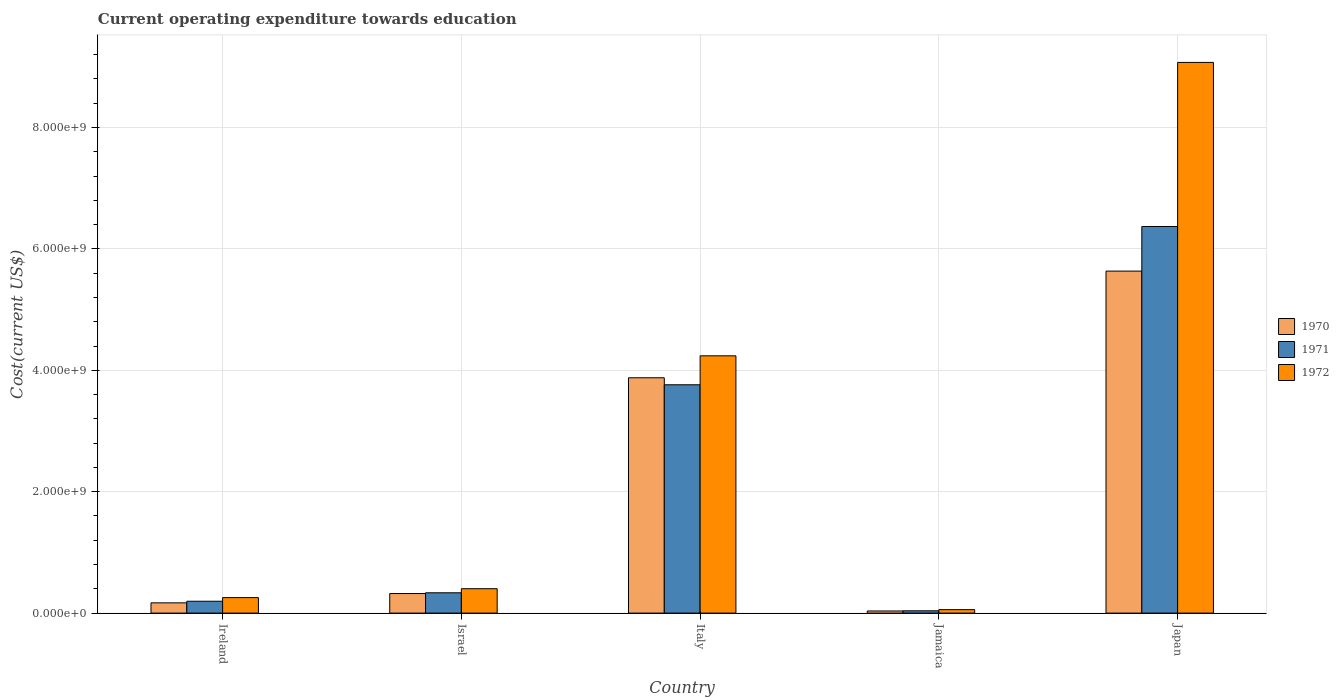Are the number of bars per tick equal to the number of legend labels?
Your answer should be very brief. Yes. Are the number of bars on each tick of the X-axis equal?
Ensure brevity in your answer.  Yes. How many bars are there on the 5th tick from the right?
Your answer should be compact. 3. What is the label of the 4th group of bars from the left?
Your answer should be very brief. Jamaica. What is the expenditure towards education in 1971 in Japan?
Your answer should be very brief. 6.37e+09. Across all countries, what is the maximum expenditure towards education in 1971?
Ensure brevity in your answer.  6.37e+09. Across all countries, what is the minimum expenditure towards education in 1972?
Give a very brief answer. 5.71e+07. In which country was the expenditure towards education in 1971 maximum?
Keep it short and to the point. Japan. In which country was the expenditure towards education in 1970 minimum?
Give a very brief answer. Jamaica. What is the total expenditure towards education in 1971 in the graph?
Keep it short and to the point. 1.07e+1. What is the difference between the expenditure towards education in 1972 in Ireland and that in Japan?
Provide a short and direct response. -8.82e+09. What is the difference between the expenditure towards education in 1971 in Japan and the expenditure towards education in 1970 in Jamaica?
Offer a terse response. 6.33e+09. What is the average expenditure towards education in 1972 per country?
Your response must be concise. 2.80e+09. What is the difference between the expenditure towards education of/in 1970 and expenditure towards education of/in 1972 in Italy?
Your response must be concise. -3.62e+08. What is the ratio of the expenditure towards education in 1970 in Ireland to that in Israel?
Offer a terse response. 0.52. What is the difference between the highest and the second highest expenditure towards education in 1972?
Keep it short and to the point. 8.67e+09. What is the difference between the highest and the lowest expenditure towards education in 1971?
Give a very brief answer. 6.33e+09. Is the sum of the expenditure towards education in 1971 in Ireland and Jamaica greater than the maximum expenditure towards education in 1972 across all countries?
Give a very brief answer. No. Is it the case that in every country, the sum of the expenditure towards education in 1972 and expenditure towards education in 1971 is greater than the expenditure towards education in 1970?
Ensure brevity in your answer.  Yes. How many bars are there?
Your answer should be compact. 15. Does the graph contain any zero values?
Provide a short and direct response. No. Does the graph contain grids?
Make the answer very short. Yes. How many legend labels are there?
Provide a succinct answer. 3. How are the legend labels stacked?
Your answer should be compact. Vertical. What is the title of the graph?
Make the answer very short. Current operating expenditure towards education. Does "1983" appear as one of the legend labels in the graph?
Your answer should be compact. No. What is the label or title of the Y-axis?
Give a very brief answer. Cost(current US$). What is the Cost(current US$) of 1970 in Ireland?
Your answer should be compact. 1.69e+08. What is the Cost(current US$) of 1971 in Ireland?
Provide a short and direct response. 1.95e+08. What is the Cost(current US$) of 1972 in Ireland?
Give a very brief answer. 2.55e+08. What is the Cost(current US$) of 1970 in Israel?
Keep it short and to the point. 3.22e+08. What is the Cost(current US$) of 1971 in Israel?
Keep it short and to the point. 3.34e+08. What is the Cost(current US$) of 1972 in Israel?
Give a very brief answer. 4.02e+08. What is the Cost(current US$) of 1970 in Italy?
Give a very brief answer. 3.88e+09. What is the Cost(current US$) in 1971 in Italy?
Your answer should be compact. 3.76e+09. What is the Cost(current US$) in 1972 in Italy?
Keep it short and to the point. 4.24e+09. What is the Cost(current US$) of 1970 in Jamaica?
Give a very brief answer. 3.49e+07. What is the Cost(current US$) of 1971 in Jamaica?
Offer a terse response. 3.77e+07. What is the Cost(current US$) of 1972 in Jamaica?
Keep it short and to the point. 5.71e+07. What is the Cost(current US$) of 1970 in Japan?
Provide a short and direct response. 5.63e+09. What is the Cost(current US$) of 1971 in Japan?
Your answer should be very brief. 6.37e+09. What is the Cost(current US$) of 1972 in Japan?
Provide a succinct answer. 9.07e+09. Across all countries, what is the maximum Cost(current US$) in 1970?
Your response must be concise. 5.63e+09. Across all countries, what is the maximum Cost(current US$) in 1971?
Make the answer very short. 6.37e+09. Across all countries, what is the maximum Cost(current US$) in 1972?
Your answer should be very brief. 9.07e+09. Across all countries, what is the minimum Cost(current US$) of 1970?
Your answer should be very brief. 3.49e+07. Across all countries, what is the minimum Cost(current US$) in 1971?
Offer a very short reply. 3.77e+07. Across all countries, what is the minimum Cost(current US$) of 1972?
Your answer should be very brief. 5.71e+07. What is the total Cost(current US$) in 1970 in the graph?
Give a very brief answer. 1.00e+1. What is the total Cost(current US$) of 1971 in the graph?
Your response must be concise. 1.07e+1. What is the total Cost(current US$) in 1972 in the graph?
Your response must be concise. 1.40e+1. What is the difference between the Cost(current US$) of 1970 in Ireland and that in Israel?
Keep it short and to the point. -1.53e+08. What is the difference between the Cost(current US$) of 1971 in Ireland and that in Israel?
Offer a very short reply. -1.39e+08. What is the difference between the Cost(current US$) of 1972 in Ireland and that in Israel?
Keep it short and to the point. -1.47e+08. What is the difference between the Cost(current US$) of 1970 in Ireland and that in Italy?
Your answer should be compact. -3.71e+09. What is the difference between the Cost(current US$) of 1971 in Ireland and that in Italy?
Provide a short and direct response. -3.57e+09. What is the difference between the Cost(current US$) in 1972 in Ireland and that in Italy?
Your answer should be very brief. -3.98e+09. What is the difference between the Cost(current US$) in 1970 in Ireland and that in Jamaica?
Provide a succinct answer. 1.34e+08. What is the difference between the Cost(current US$) of 1971 in Ireland and that in Jamaica?
Provide a succinct answer. 1.57e+08. What is the difference between the Cost(current US$) in 1972 in Ireland and that in Jamaica?
Ensure brevity in your answer.  1.98e+08. What is the difference between the Cost(current US$) of 1970 in Ireland and that in Japan?
Your answer should be compact. -5.47e+09. What is the difference between the Cost(current US$) in 1971 in Ireland and that in Japan?
Give a very brief answer. -6.17e+09. What is the difference between the Cost(current US$) of 1972 in Ireland and that in Japan?
Provide a succinct answer. -8.82e+09. What is the difference between the Cost(current US$) in 1970 in Israel and that in Italy?
Your response must be concise. -3.55e+09. What is the difference between the Cost(current US$) in 1971 in Israel and that in Italy?
Offer a terse response. -3.43e+09. What is the difference between the Cost(current US$) of 1972 in Israel and that in Italy?
Offer a terse response. -3.84e+09. What is the difference between the Cost(current US$) of 1970 in Israel and that in Jamaica?
Your answer should be very brief. 2.87e+08. What is the difference between the Cost(current US$) of 1971 in Israel and that in Jamaica?
Provide a succinct answer. 2.97e+08. What is the difference between the Cost(current US$) in 1972 in Israel and that in Jamaica?
Provide a succinct answer. 3.45e+08. What is the difference between the Cost(current US$) of 1970 in Israel and that in Japan?
Provide a short and direct response. -5.31e+09. What is the difference between the Cost(current US$) of 1971 in Israel and that in Japan?
Your answer should be very brief. -6.03e+09. What is the difference between the Cost(current US$) in 1972 in Israel and that in Japan?
Offer a terse response. -8.67e+09. What is the difference between the Cost(current US$) of 1970 in Italy and that in Jamaica?
Offer a terse response. 3.84e+09. What is the difference between the Cost(current US$) of 1971 in Italy and that in Jamaica?
Your answer should be compact. 3.72e+09. What is the difference between the Cost(current US$) in 1972 in Italy and that in Jamaica?
Your response must be concise. 4.18e+09. What is the difference between the Cost(current US$) in 1970 in Italy and that in Japan?
Your answer should be compact. -1.76e+09. What is the difference between the Cost(current US$) of 1971 in Italy and that in Japan?
Offer a very short reply. -2.61e+09. What is the difference between the Cost(current US$) of 1972 in Italy and that in Japan?
Provide a short and direct response. -4.83e+09. What is the difference between the Cost(current US$) of 1970 in Jamaica and that in Japan?
Keep it short and to the point. -5.60e+09. What is the difference between the Cost(current US$) of 1971 in Jamaica and that in Japan?
Offer a very short reply. -6.33e+09. What is the difference between the Cost(current US$) of 1972 in Jamaica and that in Japan?
Provide a short and direct response. -9.02e+09. What is the difference between the Cost(current US$) in 1970 in Ireland and the Cost(current US$) in 1971 in Israel?
Offer a very short reply. -1.66e+08. What is the difference between the Cost(current US$) of 1970 in Ireland and the Cost(current US$) of 1972 in Israel?
Offer a terse response. -2.33e+08. What is the difference between the Cost(current US$) in 1971 in Ireland and the Cost(current US$) in 1972 in Israel?
Offer a terse response. -2.07e+08. What is the difference between the Cost(current US$) in 1970 in Ireland and the Cost(current US$) in 1971 in Italy?
Give a very brief answer. -3.59e+09. What is the difference between the Cost(current US$) in 1970 in Ireland and the Cost(current US$) in 1972 in Italy?
Your answer should be compact. -4.07e+09. What is the difference between the Cost(current US$) of 1971 in Ireland and the Cost(current US$) of 1972 in Italy?
Keep it short and to the point. -4.04e+09. What is the difference between the Cost(current US$) of 1970 in Ireland and the Cost(current US$) of 1971 in Jamaica?
Ensure brevity in your answer.  1.31e+08. What is the difference between the Cost(current US$) in 1970 in Ireland and the Cost(current US$) in 1972 in Jamaica?
Provide a short and direct response. 1.12e+08. What is the difference between the Cost(current US$) in 1971 in Ireland and the Cost(current US$) in 1972 in Jamaica?
Provide a short and direct response. 1.38e+08. What is the difference between the Cost(current US$) of 1970 in Ireland and the Cost(current US$) of 1971 in Japan?
Provide a succinct answer. -6.20e+09. What is the difference between the Cost(current US$) of 1970 in Ireland and the Cost(current US$) of 1972 in Japan?
Offer a terse response. -8.90e+09. What is the difference between the Cost(current US$) in 1971 in Ireland and the Cost(current US$) in 1972 in Japan?
Ensure brevity in your answer.  -8.88e+09. What is the difference between the Cost(current US$) of 1970 in Israel and the Cost(current US$) of 1971 in Italy?
Your response must be concise. -3.44e+09. What is the difference between the Cost(current US$) in 1970 in Israel and the Cost(current US$) in 1972 in Italy?
Keep it short and to the point. -3.92e+09. What is the difference between the Cost(current US$) in 1971 in Israel and the Cost(current US$) in 1972 in Italy?
Your answer should be compact. -3.90e+09. What is the difference between the Cost(current US$) of 1970 in Israel and the Cost(current US$) of 1971 in Jamaica?
Your answer should be very brief. 2.85e+08. What is the difference between the Cost(current US$) in 1970 in Israel and the Cost(current US$) in 1972 in Jamaica?
Offer a very short reply. 2.65e+08. What is the difference between the Cost(current US$) of 1971 in Israel and the Cost(current US$) of 1972 in Jamaica?
Provide a short and direct response. 2.77e+08. What is the difference between the Cost(current US$) in 1970 in Israel and the Cost(current US$) in 1971 in Japan?
Provide a short and direct response. -6.05e+09. What is the difference between the Cost(current US$) in 1970 in Israel and the Cost(current US$) in 1972 in Japan?
Offer a terse response. -8.75e+09. What is the difference between the Cost(current US$) in 1971 in Israel and the Cost(current US$) in 1972 in Japan?
Offer a very short reply. -8.74e+09. What is the difference between the Cost(current US$) in 1970 in Italy and the Cost(current US$) in 1971 in Jamaica?
Keep it short and to the point. 3.84e+09. What is the difference between the Cost(current US$) of 1970 in Italy and the Cost(current US$) of 1972 in Jamaica?
Provide a succinct answer. 3.82e+09. What is the difference between the Cost(current US$) in 1971 in Italy and the Cost(current US$) in 1972 in Jamaica?
Provide a succinct answer. 3.70e+09. What is the difference between the Cost(current US$) in 1970 in Italy and the Cost(current US$) in 1971 in Japan?
Keep it short and to the point. -2.49e+09. What is the difference between the Cost(current US$) of 1970 in Italy and the Cost(current US$) of 1972 in Japan?
Your answer should be very brief. -5.20e+09. What is the difference between the Cost(current US$) of 1971 in Italy and the Cost(current US$) of 1972 in Japan?
Offer a very short reply. -5.31e+09. What is the difference between the Cost(current US$) of 1970 in Jamaica and the Cost(current US$) of 1971 in Japan?
Your answer should be compact. -6.33e+09. What is the difference between the Cost(current US$) in 1970 in Jamaica and the Cost(current US$) in 1972 in Japan?
Your response must be concise. -9.04e+09. What is the difference between the Cost(current US$) of 1971 in Jamaica and the Cost(current US$) of 1972 in Japan?
Your answer should be compact. -9.03e+09. What is the average Cost(current US$) of 1970 per country?
Your response must be concise. 2.01e+09. What is the average Cost(current US$) of 1971 per country?
Offer a very short reply. 2.14e+09. What is the average Cost(current US$) of 1972 per country?
Make the answer very short. 2.80e+09. What is the difference between the Cost(current US$) in 1970 and Cost(current US$) in 1971 in Ireland?
Give a very brief answer. -2.64e+07. What is the difference between the Cost(current US$) in 1970 and Cost(current US$) in 1972 in Ireland?
Provide a short and direct response. -8.62e+07. What is the difference between the Cost(current US$) in 1971 and Cost(current US$) in 1972 in Ireland?
Offer a terse response. -5.99e+07. What is the difference between the Cost(current US$) in 1970 and Cost(current US$) in 1971 in Israel?
Provide a succinct answer. -1.22e+07. What is the difference between the Cost(current US$) in 1970 and Cost(current US$) in 1972 in Israel?
Make the answer very short. -7.96e+07. What is the difference between the Cost(current US$) in 1971 and Cost(current US$) in 1972 in Israel?
Offer a terse response. -6.74e+07. What is the difference between the Cost(current US$) in 1970 and Cost(current US$) in 1971 in Italy?
Your answer should be very brief. 1.15e+08. What is the difference between the Cost(current US$) of 1970 and Cost(current US$) of 1972 in Italy?
Provide a succinct answer. -3.62e+08. What is the difference between the Cost(current US$) of 1971 and Cost(current US$) of 1972 in Italy?
Ensure brevity in your answer.  -4.77e+08. What is the difference between the Cost(current US$) in 1970 and Cost(current US$) in 1971 in Jamaica?
Ensure brevity in your answer.  -2.78e+06. What is the difference between the Cost(current US$) of 1970 and Cost(current US$) of 1972 in Jamaica?
Your answer should be very brief. -2.22e+07. What is the difference between the Cost(current US$) of 1971 and Cost(current US$) of 1972 in Jamaica?
Offer a terse response. -1.94e+07. What is the difference between the Cost(current US$) of 1970 and Cost(current US$) of 1971 in Japan?
Your answer should be compact. -7.35e+08. What is the difference between the Cost(current US$) of 1970 and Cost(current US$) of 1972 in Japan?
Your response must be concise. -3.44e+09. What is the difference between the Cost(current US$) in 1971 and Cost(current US$) in 1972 in Japan?
Your response must be concise. -2.70e+09. What is the ratio of the Cost(current US$) in 1970 in Ireland to that in Israel?
Make the answer very short. 0.52. What is the ratio of the Cost(current US$) in 1971 in Ireland to that in Israel?
Offer a very short reply. 0.58. What is the ratio of the Cost(current US$) of 1972 in Ireland to that in Israel?
Your response must be concise. 0.63. What is the ratio of the Cost(current US$) of 1970 in Ireland to that in Italy?
Give a very brief answer. 0.04. What is the ratio of the Cost(current US$) of 1971 in Ireland to that in Italy?
Offer a very short reply. 0.05. What is the ratio of the Cost(current US$) of 1972 in Ireland to that in Italy?
Keep it short and to the point. 0.06. What is the ratio of the Cost(current US$) of 1970 in Ireland to that in Jamaica?
Offer a very short reply. 4.83. What is the ratio of the Cost(current US$) in 1971 in Ireland to that in Jamaica?
Your response must be concise. 5.18. What is the ratio of the Cost(current US$) of 1972 in Ireland to that in Jamaica?
Offer a very short reply. 4.47. What is the ratio of the Cost(current US$) in 1970 in Ireland to that in Japan?
Offer a very short reply. 0.03. What is the ratio of the Cost(current US$) in 1971 in Ireland to that in Japan?
Offer a terse response. 0.03. What is the ratio of the Cost(current US$) in 1972 in Ireland to that in Japan?
Offer a very short reply. 0.03. What is the ratio of the Cost(current US$) in 1970 in Israel to that in Italy?
Provide a short and direct response. 0.08. What is the ratio of the Cost(current US$) in 1971 in Israel to that in Italy?
Your answer should be very brief. 0.09. What is the ratio of the Cost(current US$) of 1972 in Israel to that in Italy?
Your response must be concise. 0.09. What is the ratio of the Cost(current US$) in 1970 in Israel to that in Jamaica?
Offer a very short reply. 9.22. What is the ratio of the Cost(current US$) of 1971 in Israel to that in Jamaica?
Ensure brevity in your answer.  8.87. What is the ratio of the Cost(current US$) in 1972 in Israel to that in Jamaica?
Keep it short and to the point. 7.04. What is the ratio of the Cost(current US$) in 1970 in Israel to that in Japan?
Your answer should be very brief. 0.06. What is the ratio of the Cost(current US$) of 1971 in Israel to that in Japan?
Provide a short and direct response. 0.05. What is the ratio of the Cost(current US$) of 1972 in Israel to that in Japan?
Your answer should be very brief. 0.04. What is the ratio of the Cost(current US$) of 1970 in Italy to that in Jamaica?
Your answer should be compact. 110.97. What is the ratio of the Cost(current US$) of 1971 in Italy to that in Jamaica?
Your response must be concise. 99.73. What is the ratio of the Cost(current US$) in 1972 in Italy to that in Jamaica?
Your answer should be very brief. 74.21. What is the ratio of the Cost(current US$) of 1970 in Italy to that in Japan?
Offer a very short reply. 0.69. What is the ratio of the Cost(current US$) of 1971 in Italy to that in Japan?
Your answer should be compact. 0.59. What is the ratio of the Cost(current US$) of 1972 in Italy to that in Japan?
Your answer should be compact. 0.47. What is the ratio of the Cost(current US$) of 1970 in Jamaica to that in Japan?
Make the answer very short. 0.01. What is the ratio of the Cost(current US$) in 1971 in Jamaica to that in Japan?
Your answer should be very brief. 0.01. What is the ratio of the Cost(current US$) of 1972 in Jamaica to that in Japan?
Your answer should be compact. 0.01. What is the difference between the highest and the second highest Cost(current US$) of 1970?
Keep it short and to the point. 1.76e+09. What is the difference between the highest and the second highest Cost(current US$) of 1971?
Your response must be concise. 2.61e+09. What is the difference between the highest and the second highest Cost(current US$) of 1972?
Offer a very short reply. 4.83e+09. What is the difference between the highest and the lowest Cost(current US$) of 1970?
Provide a succinct answer. 5.60e+09. What is the difference between the highest and the lowest Cost(current US$) in 1971?
Ensure brevity in your answer.  6.33e+09. What is the difference between the highest and the lowest Cost(current US$) of 1972?
Provide a short and direct response. 9.02e+09. 